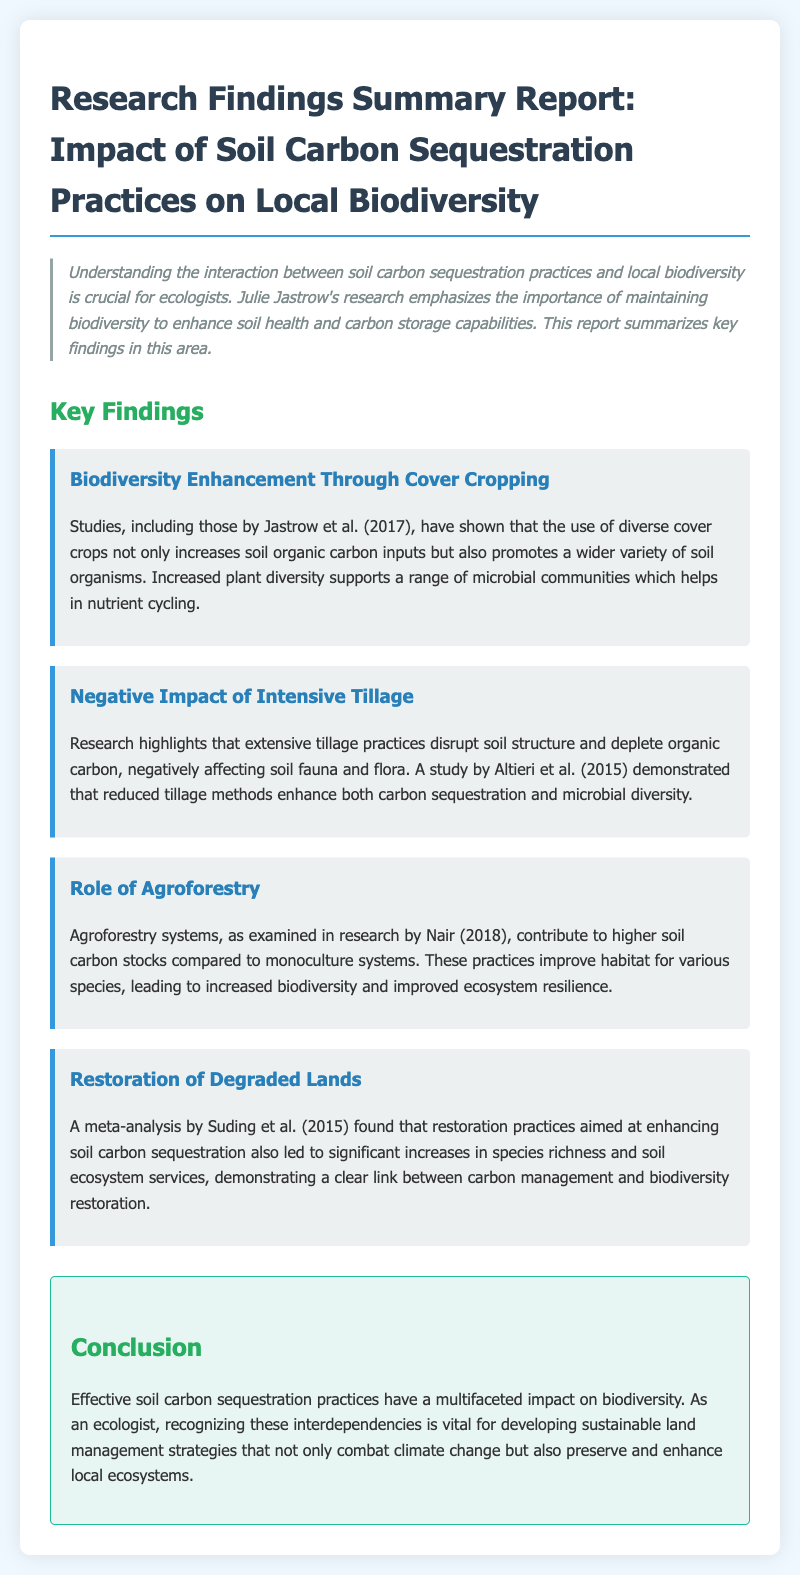What is the title of the report? The title of the report is explicitly stated at the start of the document.
Answer: Research Findings Summary Report: Impact of Soil Carbon Sequestration Practices on Local Biodiversity Who conducted the study on cover cropping? The document mentions a study by Jastrow et al., highlighting their contributions to understanding cover cropping.
Answer: Jastrow et al. (2017) What negative impact does extensive tillage have? The report specifies the detrimental effects of extensive tillage practices on soil health and biodiversity.
Answer: Disrupt soil structure and deplete organic carbon Which practice enhances soil carbon stocks compared to monoculture systems? The findings related to agroforestry systems indicate their benefits over monoculture for soil carbon.
Answer: Agroforestry Who analyzed the restoration practices for increasing species richness? The document references a meta-analysis for restoration practices conducted by Suding et al.
Answer: Suding et al. (2015) What is the main conclusion of the report? The report summarizes the key takeaway about the relationship between carbon sequestration practices and biodiversity.
Answer: Effective soil carbon sequestration practices have a multifaceted impact on biodiversity What effect do diverse cover crops have on soil organisms? The findings specify the positive impact of diverse cover crops on soil biodiversity.
Answer: Promotes a wider variety of soil organisms Which year was the study by Altieri et al. published? The document provides in-text citation for Altieri et al., indicating the year of publication for their findings.
Answer: 2015 